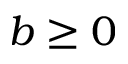<formula> <loc_0><loc_0><loc_500><loc_500>b \geq 0</formula> 